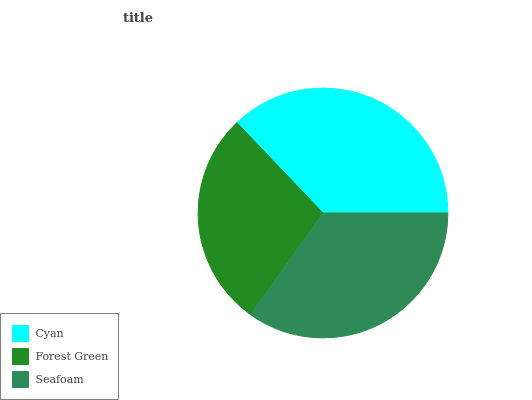Is Forest Green the minimum?
Answer yes or no. Yes. Is Cyan the maximum?
Answer yes or no. Yes. Is Seafoam the minimum?
Answer yes or no. No. Is Seafoam the maximum?
Answer yes or no. No. Is Seafoam greater than Forest Green?
Answer yes or no. Yes. Is Forest Green less than Seafoam?
Answer yes or no. Yes. Is Forest Green greater than Seafoam?
Answer yes or no. No. Is Seafoam less than Forest Green?
Answer yes or no. No. Is Seafoam the high median?
Answer yes or no. Yes. Is Seafoam the low median?
Answer yes or no. Yes. Is Forest Green the high median?
Answer yes or no. No. Is Forest Green the low median?
Answer yes or no. No. 